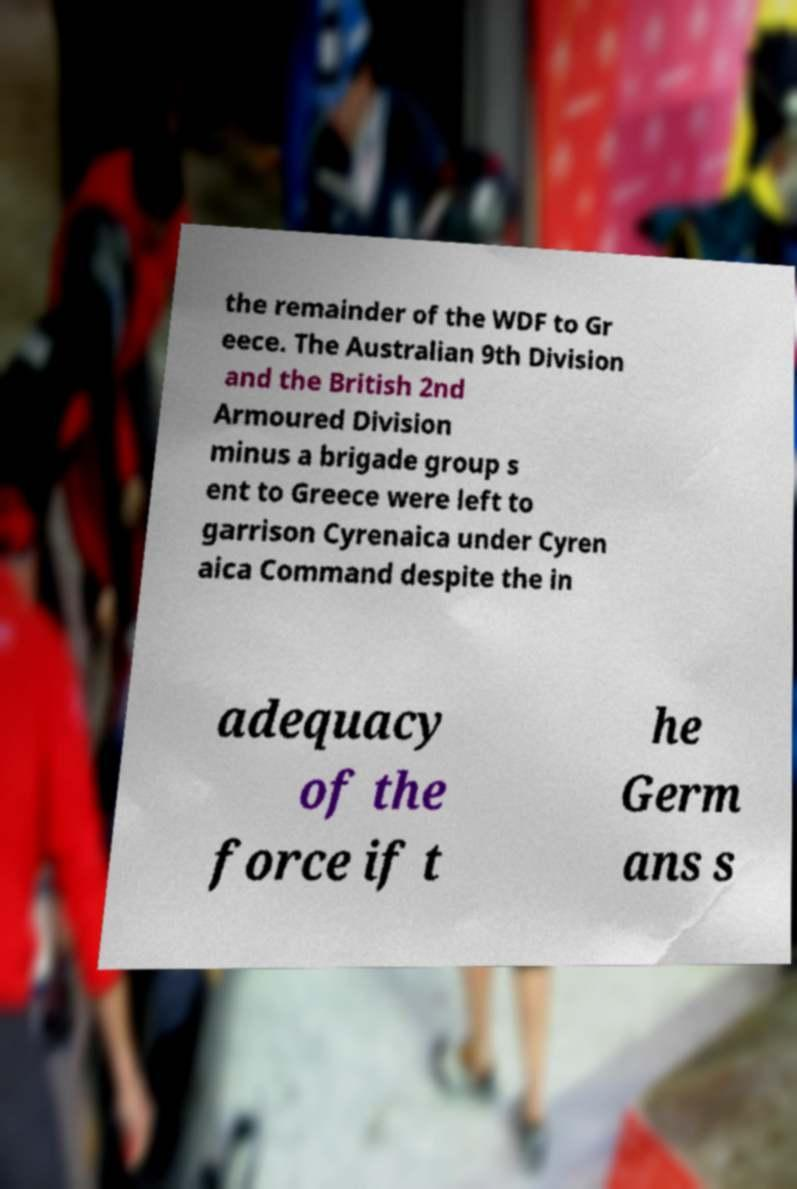Can you accurately transcribe the text from the provided image for me? the remainder of the WDF to Gr eece. The Australian 9th Division and the British 2nd Armoured Division minus a brigade group s ent to Greece were left to garrison Cyrenaica under Cyren aica Command despite the in adequacy of the force if t he Germ ans s 